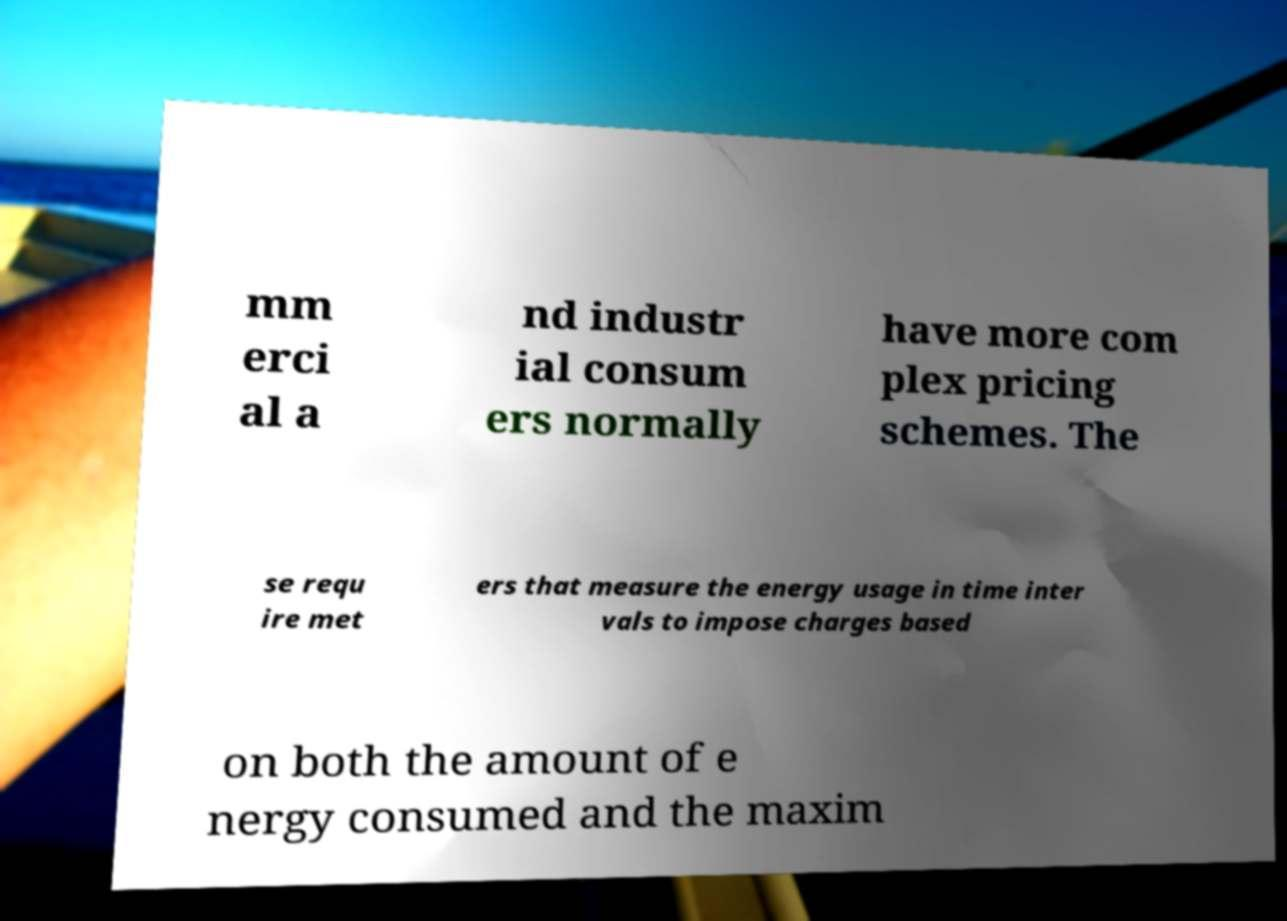Can you accurately transcribe the text from the provided image for me? mm erci al a nd industr ial consum ers normally have more com plex pricing schemes. The se requ ire met ers that measure the energy usage in time inter vals to impose charges based on both the amount of e nergy consumed and the maxim 